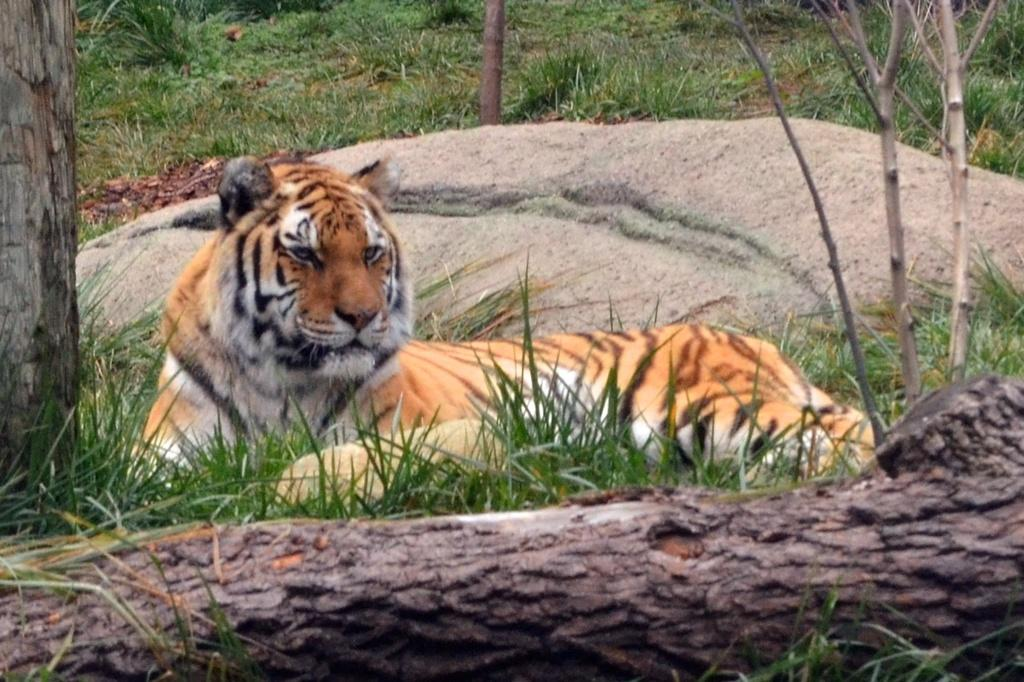What type of animal is in the image? There is a tiger in the image. Where is the tiger located? The tiger is on the grass. What can be seen in the background of the image? Tree branches are visible in the image, and the background includes grass. What type of hat is the tiger wearing in the image? There is no hat present in the image; the tiger is not wearing any clothing or accessories. Can you see a volleyball being played in the image? There is no volleyball or any indication of a game being played in the image. 